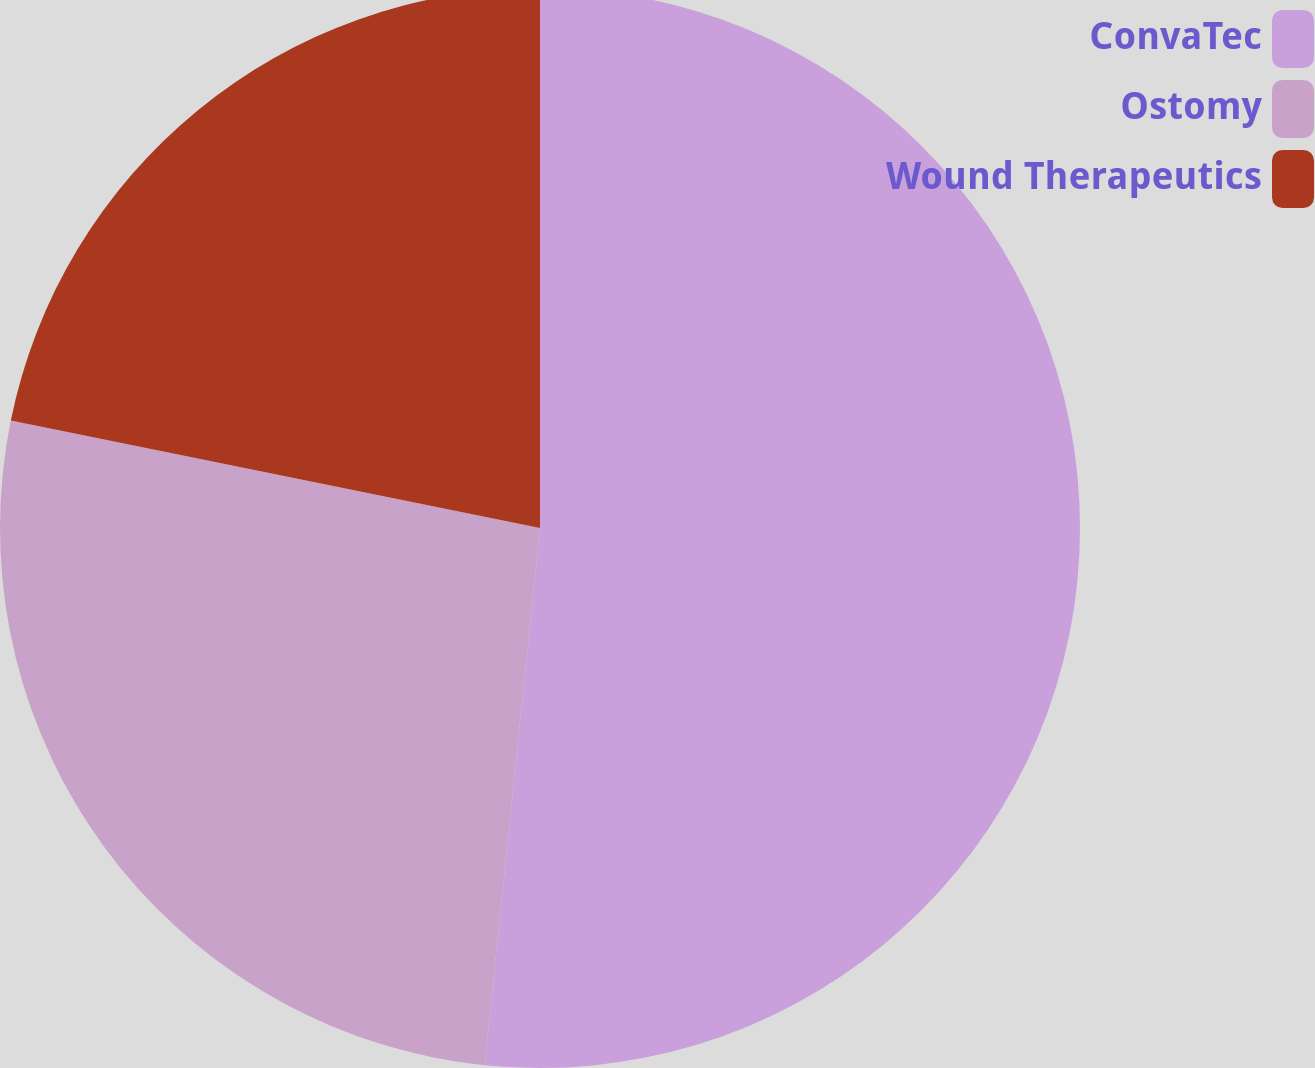<chart> <loc_0><loc_0><loc_500><loc_500><pie_chart><fcel>ConvaTec<fcel>Ostomy<fcel>Wound Therapeutics<nl><fcel>51.63%<fcel>26.55%<fcel>21.81%<nl></chart> 